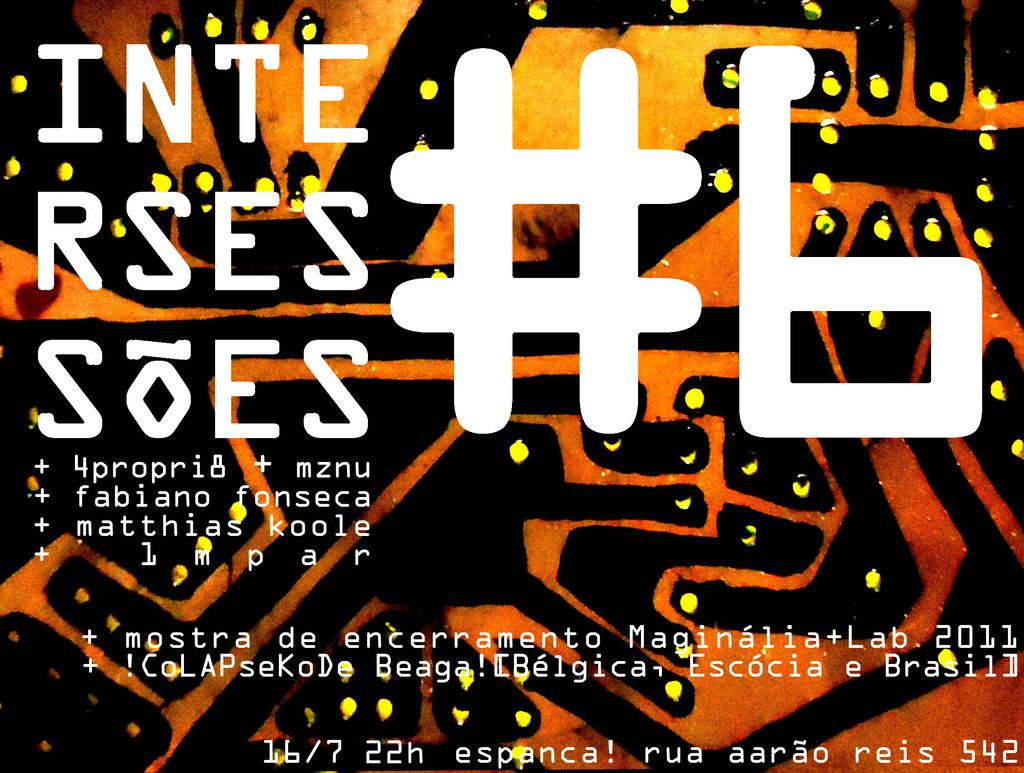Provide a one-sentence caption for the provided image. A poster advertises an event called "Inte Rses Soes.". 